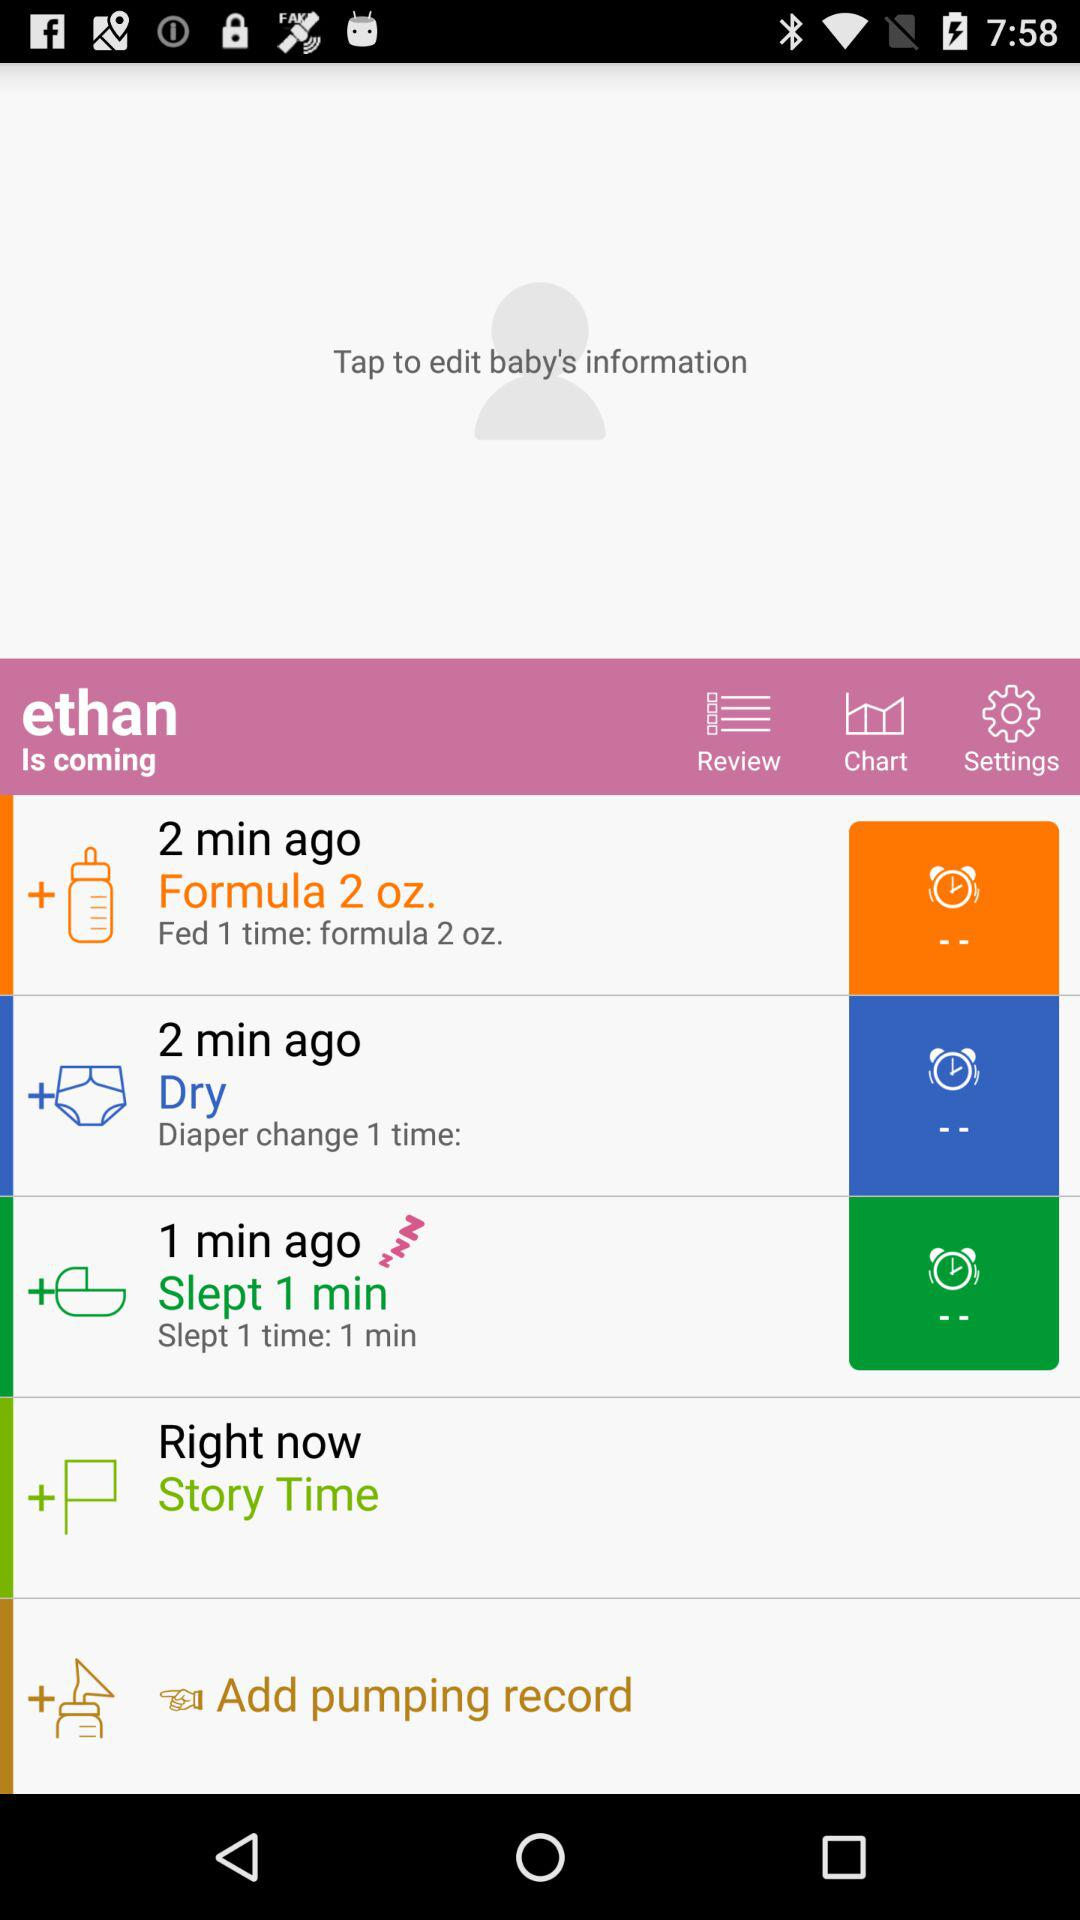What is the quantity of the formula? The quantity of the formula is 2 ounces. 